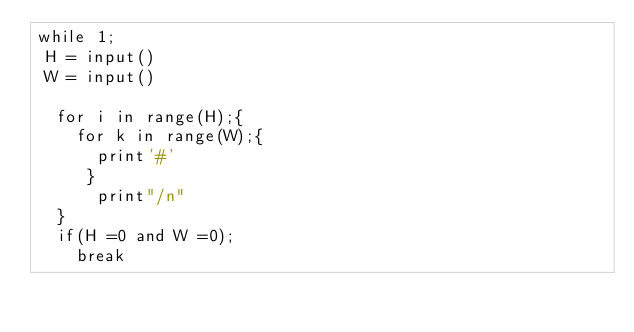Convert code to text. <code><loc_0><loc_0><loc_500><loc_500><_Python_>while 1;
 H = input()
 W = input()

  for i in range(H);{
    for k in range(W);{
      print'#'
     }
      print"/n"
  }
  if(H =0 and W =0);
    break</code> 